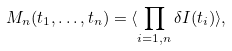<formula> <loc_0><loc_0><loc_500><loc_500>M _ { n } ( t _ { 1 } , \dots , t _ { n } ) = \langle \prod _ { i = 1 , n } \delta I ( t _ { i } ) \rangle ,</formula> 